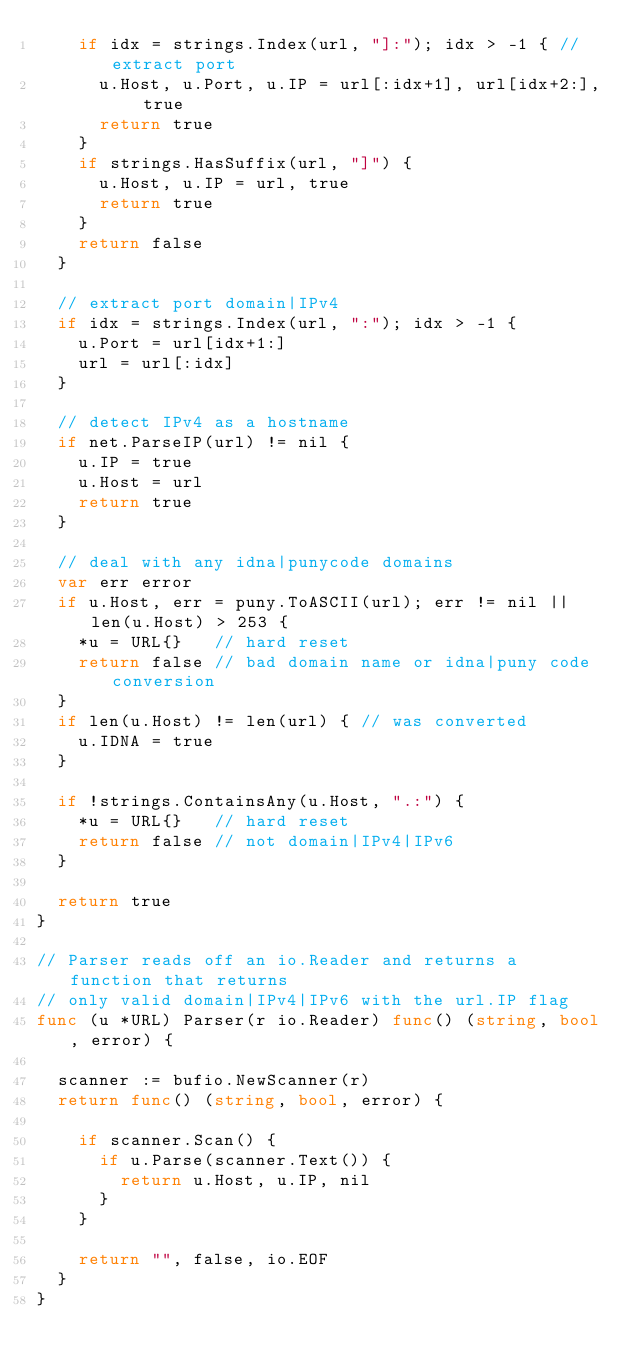<code> <loc_0><loc_0><loc_500><loc_500><_Go_>		if idx = strings.Index(url, "]:"); idx > -1 { // extract port
			u.Host, u.Port, u.IP = url[:idx+1], url[idx+2:], true
			return true
		}
		if strings.HasSuffix(url, "]") {
			u.Host, u.IP = url, true
			return true
		}
		return false
	}

	// extract port domain|IPv4
	if idx = strings.Index(url, ":"); idx > -1 {
		u.Port = url[idx+1:]
		url = url[:idx]
	}

	// detect IPv4 as a hostname
	if net.ParseIP(url) != nil {
		u.IP = true
		u.Host = url
		return true
	}

	// deal with any idna|punycode domains
	var err error
	if u.Host, err = puny.ToASCII(url); err != nil || len(u.Host) > 253 {
		*u = URL{}   // hard reset
		return false // bad domain name or idna|puny code conversion
	}
	if len(u.Host) != len(url) { // was converted
		u.IDNA = true
	}

	if !strings.ContainsAny(u.Host, ".:") {
		*u = URL{}   // hard reset
		return false // not domain|IPv4|IPv6
	}

	return true
}

// Parser reads off an io.Reader and returns a function that returns
// only valid domain|IPv4|IPv6 with the url.IP flag
func (u *URL) Parser(r io.Reader) func() (string, bool, error) {

	scanner := bufio.NewScanner(r)
	return func() (string, bool, error) {

		if scanner.Scan() {
			if u.Parse(scanner.Text()) {
				return u.Host, u.IP, nil
			}
		}

		return "", false, io.EOF
	}
}
</code> 